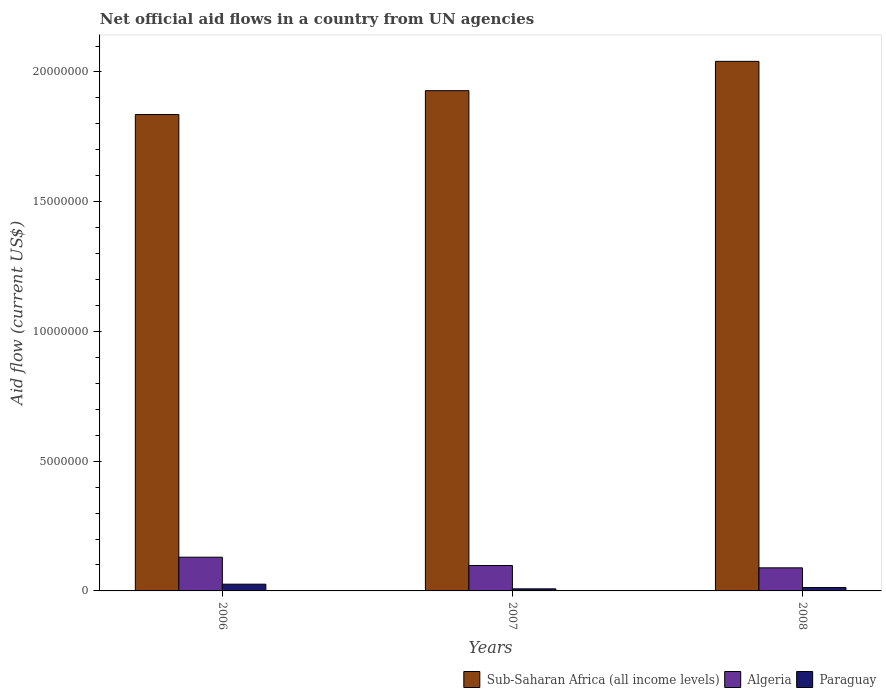How many different coloured bars are there?
Your response must be concise. 3. How many groups of bars are there?
Provide a short and direct response. 3. How many bars are there on the 2nd tick from the right?
Offer a very short reply. 3. What is the label of the 3rd group of bars from the left?
Your answer should be compact. 2008. In how many cases, is the number of bars for a given year not equal to the number of legend labels?
Your answer should be very brief. 0. What is the net official aid flow in Algeria in 2008?
Offer a terse response. 8.90e+05. Across all years, what is the maximum net official aid flow in Sub-Saharan Africa (all income levels)?
Make the answer very short. 2.04e+07. Across all years, what is the minimum net official aid flow in Paraguay?
Ensure brevity in your answer.  8.00e+04. In which year was the net official aid flow in Algeria maximum?
Provide a short and direct response. 2006. In which year was the net official aid flow in Algeria minimum?
Provide a succinct answer. 2008. What is the total net official aid flow in Algeria in the graph?
Your answer should be compact. 3.17e+06. What is the difference between the net official aid flow in Algeria in 2006 and that in 2008?
Provide a succinct answer. 4.10e+05. What is the difference between the net official aid flow in Algeria in 2008 and the net official aid flow in Sub-Saharan Africa (all income levels) in 2006?
Make the answer very short. -1.75e+07. What is the average net official aid flow in Algeria per year?
Your answer should be very brief. 1.06e+06. In the year 2007, what is the difference between the net official aid flow in Paraguay and net official aid flow in Algeria?
Your answer should be very brief. -9.00e+05. What is the ratio of the net official aid flow in Paraguay in 2006 to that in 2007?
Make the answer very short. 3.25. Is the net official aid flow in Paraguay in 2007 less than that in 2008?
Ensure brevity in your answer.  Yes. What is the difference between the highest and the lowest net official aid flow in Sub-Saharan Africa (all income levels)?
Offer a very short reply. 2.05e+06. Is the sum of the net official aid flow in Paraguay in 2006 and 2008 greater than the maximum net official aid flow in Sub-Saharan Africa (all income levels) across all years?
Keep it short and to the point. No. What does the 1st bar from the left in 2007 represents?
Provide a succinct answer. Sub-Saharan Africa (all income levels). What does the 1st bar from the right in 2008 represents?
Your answer should be very brief. Paraguay. Is it the case that in every year, the sum of the net official aid flow in Algeria and net official aid flow in Sub-Saharan Africa (all income levels) is greater than the net official aid flow in Paraguay?
Your answer should be compact. Yes. What is the difference between two consecutive major ticks on the Y-axis?
Provide a succinct answer. 5.00e+06. Are the values on the major ticks of Y-axis written in scientific E-notation?
Provide a succinct answer. No. Does the graph contain any zero values?
Your answer should be very brief. No. How are the legend labels stacked?
Your response must be concise. Horizontal. What is the title of the graph?
Make the answer very short. Net official aid flows in a country from UN agencies. Does "Moldova" appear as one of the legend labels in the graph?
Your response must be concise. No. What is the label or title of the Y-axis?
Provide a short and direct response. Aid flow (current US$). What is the Aid flow (current US$) of Sub-Saharan Africa (all income levels) in 2006?
Your response must be concise. 1.84e+07. What is the Aid flow (current US$) in Algeria in 2006?
Your answer should be compact. 1.30e+06. What is the Aid flow (current US$) of Paraguay in 2006?
Ensure brevity in your answer.  2.60e+05. What is the Aid flow (current US$) in Sub-Saharan Africa (all income levels) in 2007?
Provide a succinct answer. 1.93e+07. What is the Aid flow (current US$) of Algeria in 2007?
Give a very brief answer. 9.80e+05. What is the Aid flow (current US$) in Sub-Saharan Africa (all income levels) in 2008?
Offer a very short reply. 2.04e+07. What is the Aid flow (current US$) in Algeria in 2008?
Your answer should be very brief. 8.90e+05. What is the Aid flow (current US$) of Paraguay in 2008?
Provide a short and direct response. 1.30e+05. Across all years, what is the maximum Aid flow (current US$) of Sub-Saharan Africa (all income levels)?
Make the answer very short. 2.04e+07. Across all years, what is the maximum Aid flow (current US$) of Algeria?
Your answer should be very brief. 1.30e+06. Across all years, what is the minimum Aid flow (current US$) in Sub-Saharan Africa (all income levels)?
Your answer should be compact. 1.84e+07. Across all years, what is the minimum Aid flow (current US$) of Algeria?
Provide a short and direct response. 8.90e+05. Across all years, what is the minimum Aid flow (current US$) of Paraguay?
Give a very brief answer. 8.00e+04. What is the total Aid flow (current US$) in Sub-Saharan Africa (all income levels) in the graph?
Your response must be concise. 5.80e+07. What is the total Aid flow (current US$) in Algeria in the graph?
Provide a succinct answer. 3.17e+06. What is the total Aid flow (current US$) of Paraguay in the graph?
Provide a succinct answer. 4.70e+05. What is the difference between the Aid flow (current US$) of Sub-Saharan Africa (all income levels) in 2006 and that in 2007?
Provide a short and direct response. -9.20e+05. What is the difference between the Aid flow (current US$) in Algeria in 2006 and that in 2007?
Ensure brevity in your answer.  3.20e+05. What is the difference between the Aid flow (current US$) of Paraguay in 2006 and that in 2007?
Provide a short and direct response. 1.80e+05. What is the difference between the Aid flow (current US$) in Sub-Saharan Africa (all income levels) in 2006 and that in 2008?
Your answer should be compact. -2.05e+06. What is the difference between the Aid flow (current US$) of Algeria in 2006 and that in 2008?
Give a very brief answer. 4.10e+05. What is the difference between the Aid flow (current US$) of Sub-Saharan Africa (all income levels) in 2007 and that in 2008?
Offer a terse response. -1.13e+06. What is the difference between the Aid flow (current US$) of Paraguay in 2007 and that in 2008?
Offer a very short reply. -5.00e+04. What is the difference between the Aid flow (current US$) in Sub-Saharan Africa (all income levels) in 2006 and the Aid flow (current US$) in Algeria in 2007?
Your answer should be very brief. 1.74e+07. What is the difference between the Aid flow (current US$) of Sub-Saharan Africa (all income levels) in 2006 and the Aid flow (current US$) of Paraguay in 2007?
Your answer should be very brief. 1.83e+07. What is the difference between the Aid flow (current US$) in Algeria in 2006 and the Aid flow (current US$) in Paraguay in 2007?
Offer a very short reply. 1.22e+06. What is the difference between the Aid flow (current US$) in Sub-Saharan Africa (all income levels) in 2006 and the Aid flow (current US$) in Algeria in 2008?
Provide a succinct answer. 1.75e+07. What is the difference between the Aid flow (current US$) of Sub-Saharan Africa (all income levels) in 2006 and the Aid flow (current US$) of Paraguay in 2008?
Make the answer very short. 1.82e+07. What is the difference between the Aid flow (current US$) of Algeria in 2006 and the Aid flow (current US$) of Paraguay in 2008?
Your answer should be very brief. 1.17e+06. What is the difference between the Aid flow (current US$) of Sub-Saharan Africa (all income levels) in 2007 and the Aid flow (current US$) of Algeria in 2008?
Ensure brevity in your answer.  1.84e+07. What is the difference between the Aid flow (current US$) in Sub-Saharan Africa (all income levels) in 2007 and the Aid flow (current US$) in Paraguay in 2008?
Give a very brief answer. 1.92e+07. What is the difference between the Aid flow (current US$) of Algeria in 2007 and the Aid flow (current US$) of Paraguay in 2008?
Your answer should be very brief. 8.50e+05. What is the average Aid flow (current US$) of Sub-Saharan Africa (all income levels) per year?
Ensure brevity in your answer.  1.94e+07. What is the average Aid flow (current US$) in Algeria per year?
Offer a very short reply. 1.06e+06. What is the average Aid flow (current US$) of Paraguay per year?
Keep it short and to the point. 1.57e+05. In the year 2006, what is the difference between the Aid flow (current US$) in Sub-Saharan Africa (all income levels) and Aid flow (current US$) in Algeria?
Your answer should be very brief. 1.71e+07. In the year 2006, what is the difference between the Aid flow (current US$) in Sub-Saharan Africa (all income levels) and Aid flow (current US$) in Paraguay?
Your answer should be compact. 1.81e+07. In the year 2006, what is the difference between the Aid flow (current US$) in Algeria and Aid flow (current US$) in Paraguay?
Keep it short and to the point. 1.04e+06. In the year 2007, what is the difference between the Aid flow (current US$) in Sub-Saharan Africa (all income levels) and Aid flow (current US$) in Algeria?
Ensure brevity in your answer.  1.83e+07. In the year 2007, what is the difference between the Aid flow (current US$) in Sub-Saharan Africa (all income levels) and Aid flow (current US$) in Paraguay?
Keep it short and to the point. 1.92e+07. In the year 2008, what is the difference between the Aid flow (current US$) of Sub-Saharan Africa (all income levels) and Aid flow (current US$) of Algeria?
Provide a succinct answer. 1.95e+07. In the year 2008, what is the difference between the Aid flow (current US$) of Sub-Saharan Africa (all income levels) and Aid flow (current US$) of Paraguay?
Offer a very short reply. 2.03e+07. In the year 2008, what is the difference between the Aid flow (current US$) of Algeria and Aid flow (current US$) of Paraguay?
Offer a very short reply. 7.60e+05. What is the ratio of the Aid flow (current US$) in Sub-Saharan Africa (all income levels) in 2006 to that in 2007?
Make the answer very short. 0.95. What is the ratio of the Aid flow (current US$) in Algeria in 2006 to that in 2007?
Your response must be concise. 1.33. What is the ratio of the Aid flow (current US$) in Paraguay in 2006 to that in 2007?
Your response must be concise. 3.25. What is the ratio of the Aid flow (current US$) in Sub-Saharan Africa (all income levels) in 2006 to that in 2008?
Offer a terse response. 0.9. What is the ratio of the Aid flow (current US$) of Algeria in 2006 to that in 2008?
Keep it short and to the point. 1.46. What is the ratio of the Aid flow (current US$) in Paraguay in 2006 to that in 2008?
Give a very brief answer. 2. What is the ratio of the Aid flow (current US$) in Sub-Saharan Africa (all income levels) in 2007 to that in 2008?
Provide a short and direct response. 0.94. What is the ratio of the Aid flow (current US$) in Algeria in 2007 to that in 2008?
Your answer should be compact. 1.1. What is the ratio of the Aid flow (current US$) of Paraguay in 2007 to that in 2008?
Offer a terse response. 0.62. What is the difference between the highest and the second highest Aid flow (current US$) in Sub-Saharan Africa (all income levels)?
Offer a very short reply. 1.13e+06. What is the difference between the highest and the lowest Aid flow (current US$) in Sub-Saharan Africa (all income levels)?
Provide a succinct answer. 2.05e+06. 